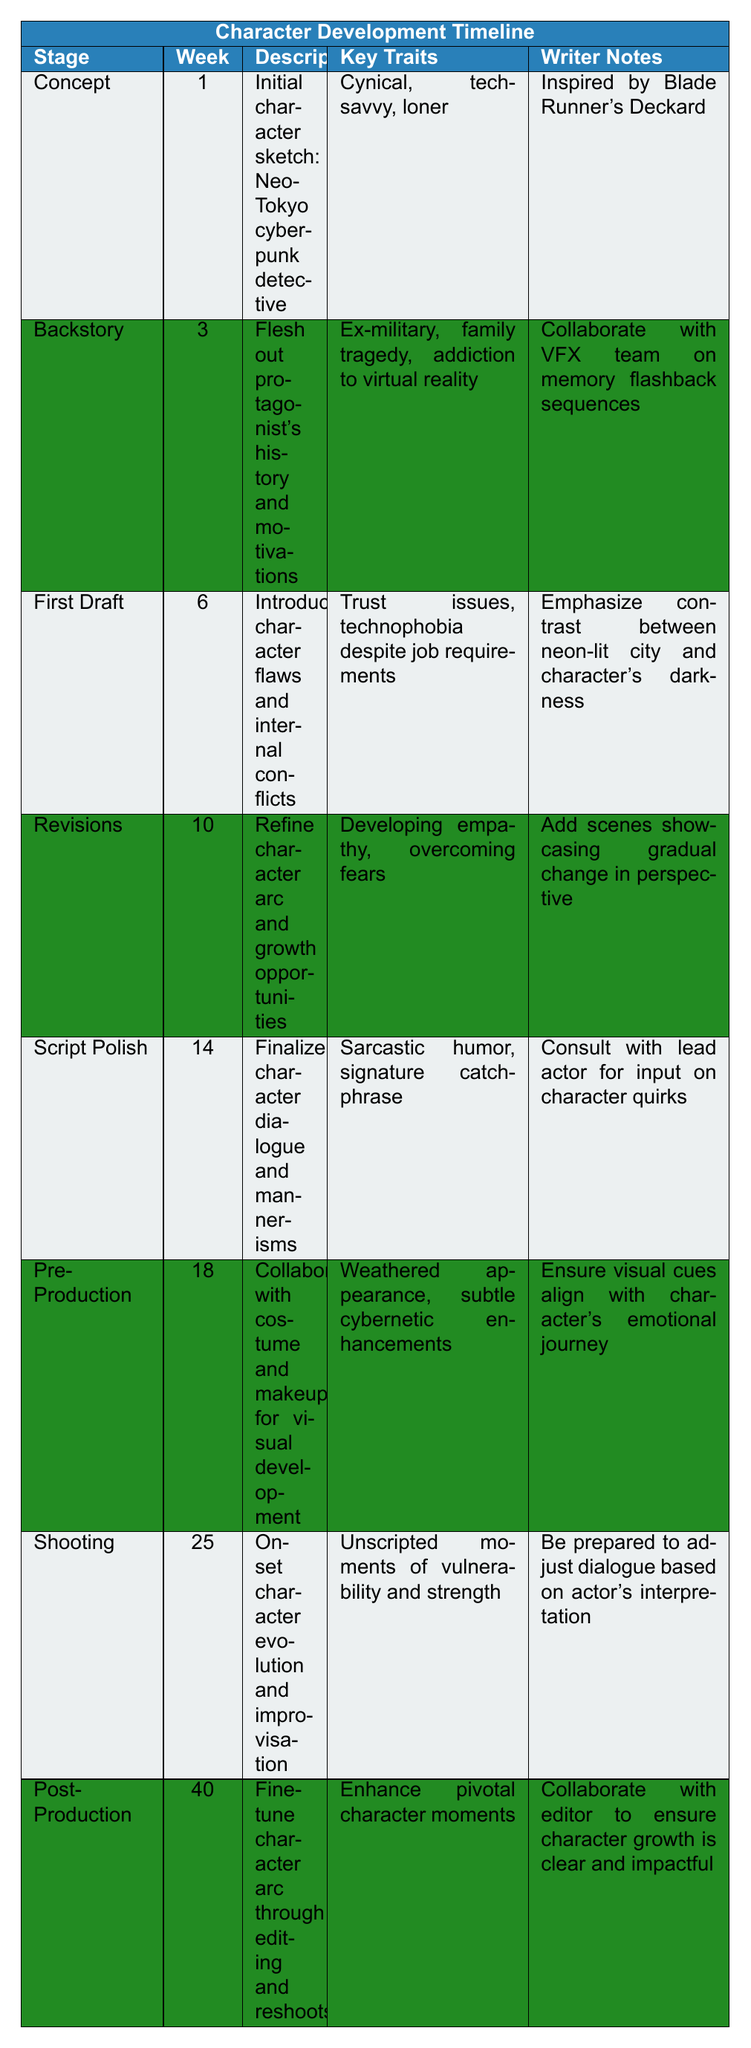What is the key trait mentioned for the "Concept" stage? The table indicates that the key traits for the "Concept" stage are "Cynical, tech-savvy, loner." Therefore, the trait is easily retrieved from the corresponding row.
Answer: Cynical, tech-savvy, loner In which week does the "Shooting" stage occur? By referring to the "Shooting" stage in the table, it is stated that it occurs in "Week 25." This information can be directly read from the respective row.
Answer: Week 25 True or False: The protagonist has a family tragedy as part of their backstory. Reviewing the "Backstory" stage, it is clear that one key trait listed is "family tragedy." Hence, the statement is true.
Answer: True What are the key traits of the main protagonist by the "Revisions" stage? From the "Revisions" stage in the table, the key traits are "Developing empathy, overcoming fears." Thus, this information can be directly identified.
Answer: Developing empathy, overcoming fears How many weeks are there between the "First Draft" and "Script Polish" stages? The "First Draft" stage occurs in Week 6, and the "Script Polish" stage occurs in Week 14. The difference is calculated as 14 - 6 = 8 weeks.
Answer: 8 weeks What stage comes immediately after "Backstory"? The table indicates that the stage that follows "Backstory" is "First Draft," as it is arranged chronologically. This could be seen by checking the order of the stages.
Answer: First Draft What was the focus of the character's development during the "Post-Production" stage? In the "Post-Production" stage, the focus is to "fine-tune character arc through editing and reshoots," as mentioned in the description. This indicates a stage of refinement.
Answer: Fine-tune character arc through editing and reshoots How does the character's key traits evolve from the "Concept" to the "Shooting" stage? In the "Concept" stage, the traits were "Cynical, tech-savvy, loner." By the "Shooting" stage, the traits include "Unscripted moments of vulnerability and strength." This reflects a shift from a more static identity to one that allows for emotional depth and growth. The evolution can be tracked by comparing the traits in both stages.
Answer: From static traits to emotional depth and growth What was one notable action during pre-production regarding the character? The "Pre-Production" stage notes collaborating with costume and makeup for visual development, which emphasizes aligning visual cues with the character's emotional journey. This indicates a strong link between visual representation and character depth.
Answer: Collaborate with costume and makeup for visual development 